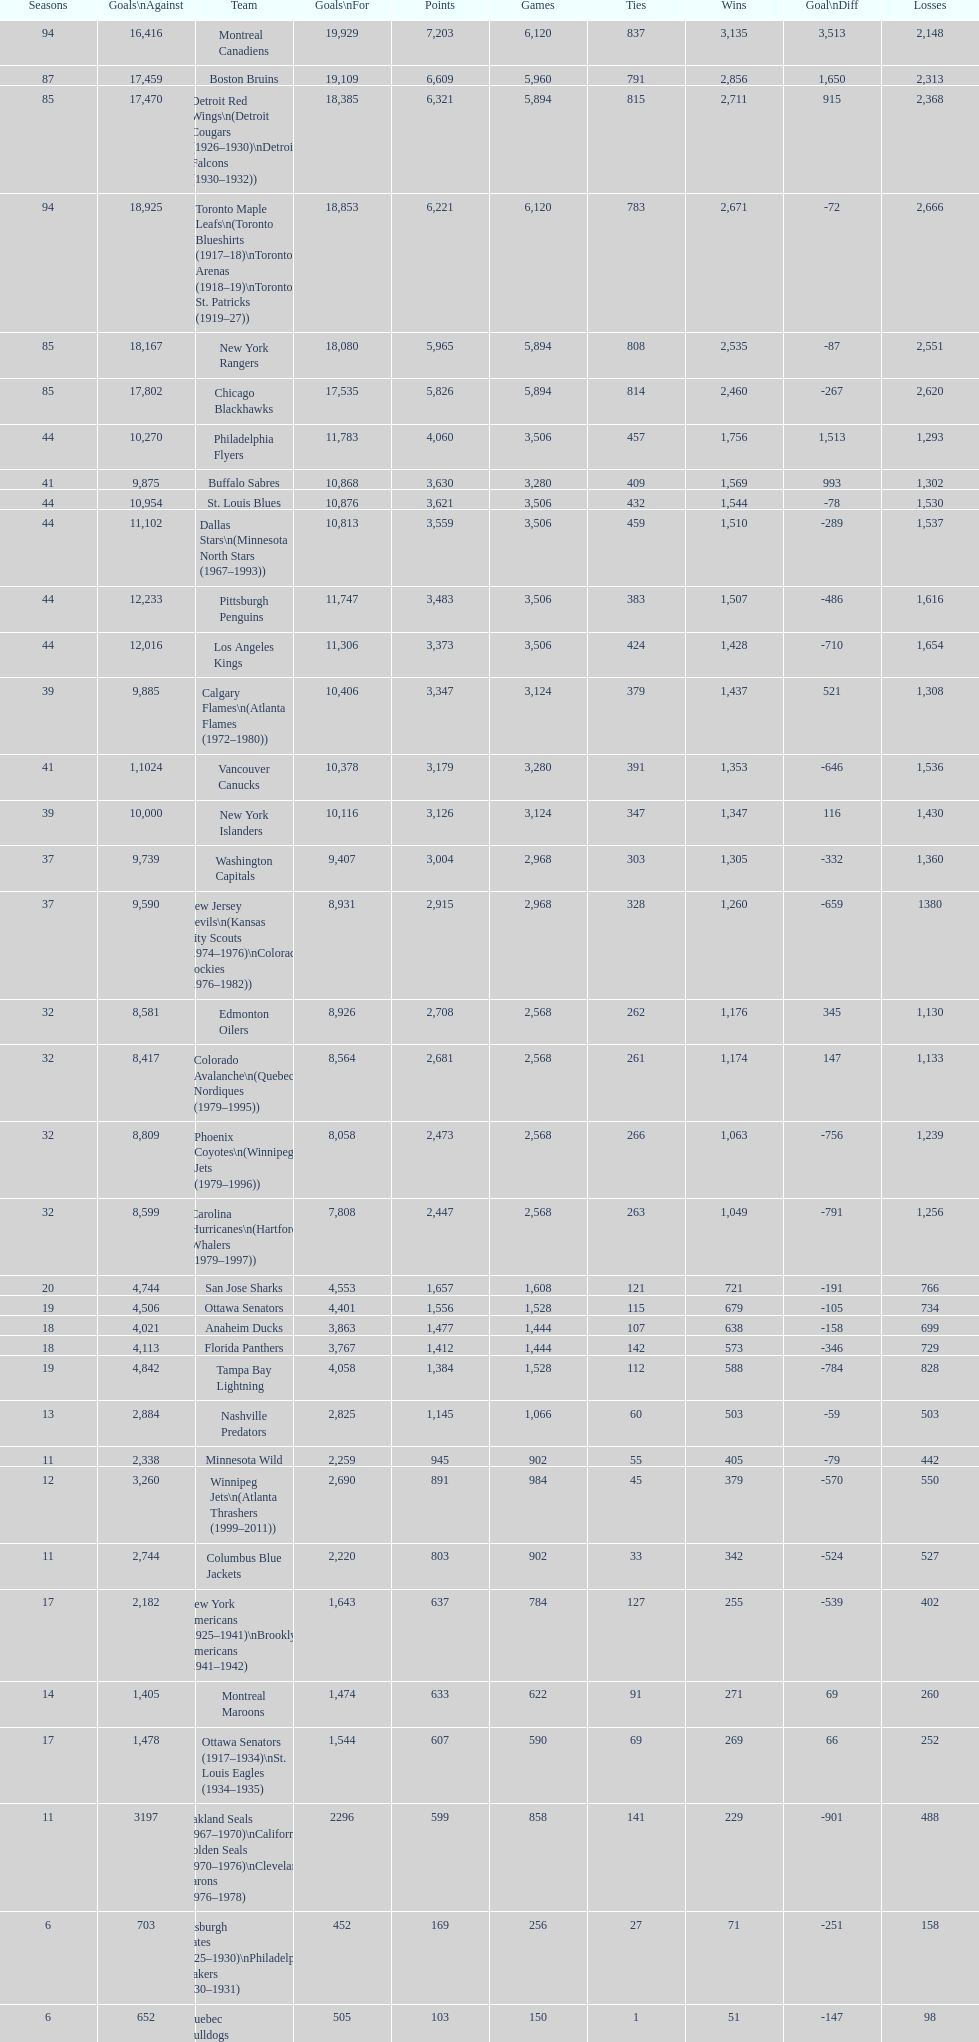What is the number of games that the vancouver canucks have won up to this point? 1,353. 